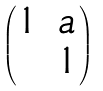<formula> <loc_0><loc_0><loc_500><loc_500>\begin{pmatrix} 1 & a \\ & 1 \end{pmatrix}</formula> 